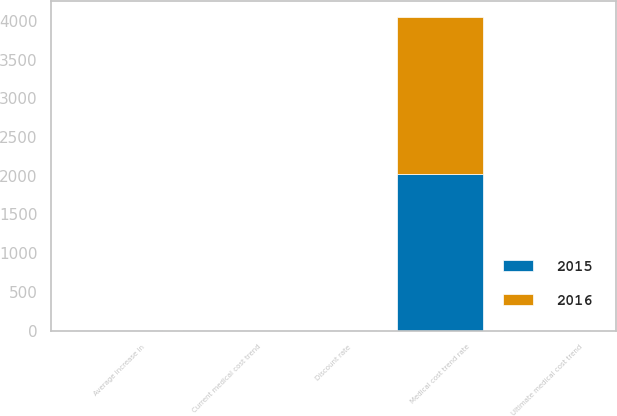Convert chart. <chart><loc_0><loc_0><loc_500><loc_500><stacked_bar_chart><ecel><fcel>Discount rate<fcel>Average increase in<fcel>Current medical cost trend<fcel>Ultimate medical cost trend<fcel>Medical cost trend rate<nl><fcel>2016<fcel>3.5<fcel>3<fcel>6<fcel>3.5<fcel>2028<nl><fcel>2015<fcel>4<fcel>3<fcel>7<fcel>3.5<fcel>2028<nl></chart> 